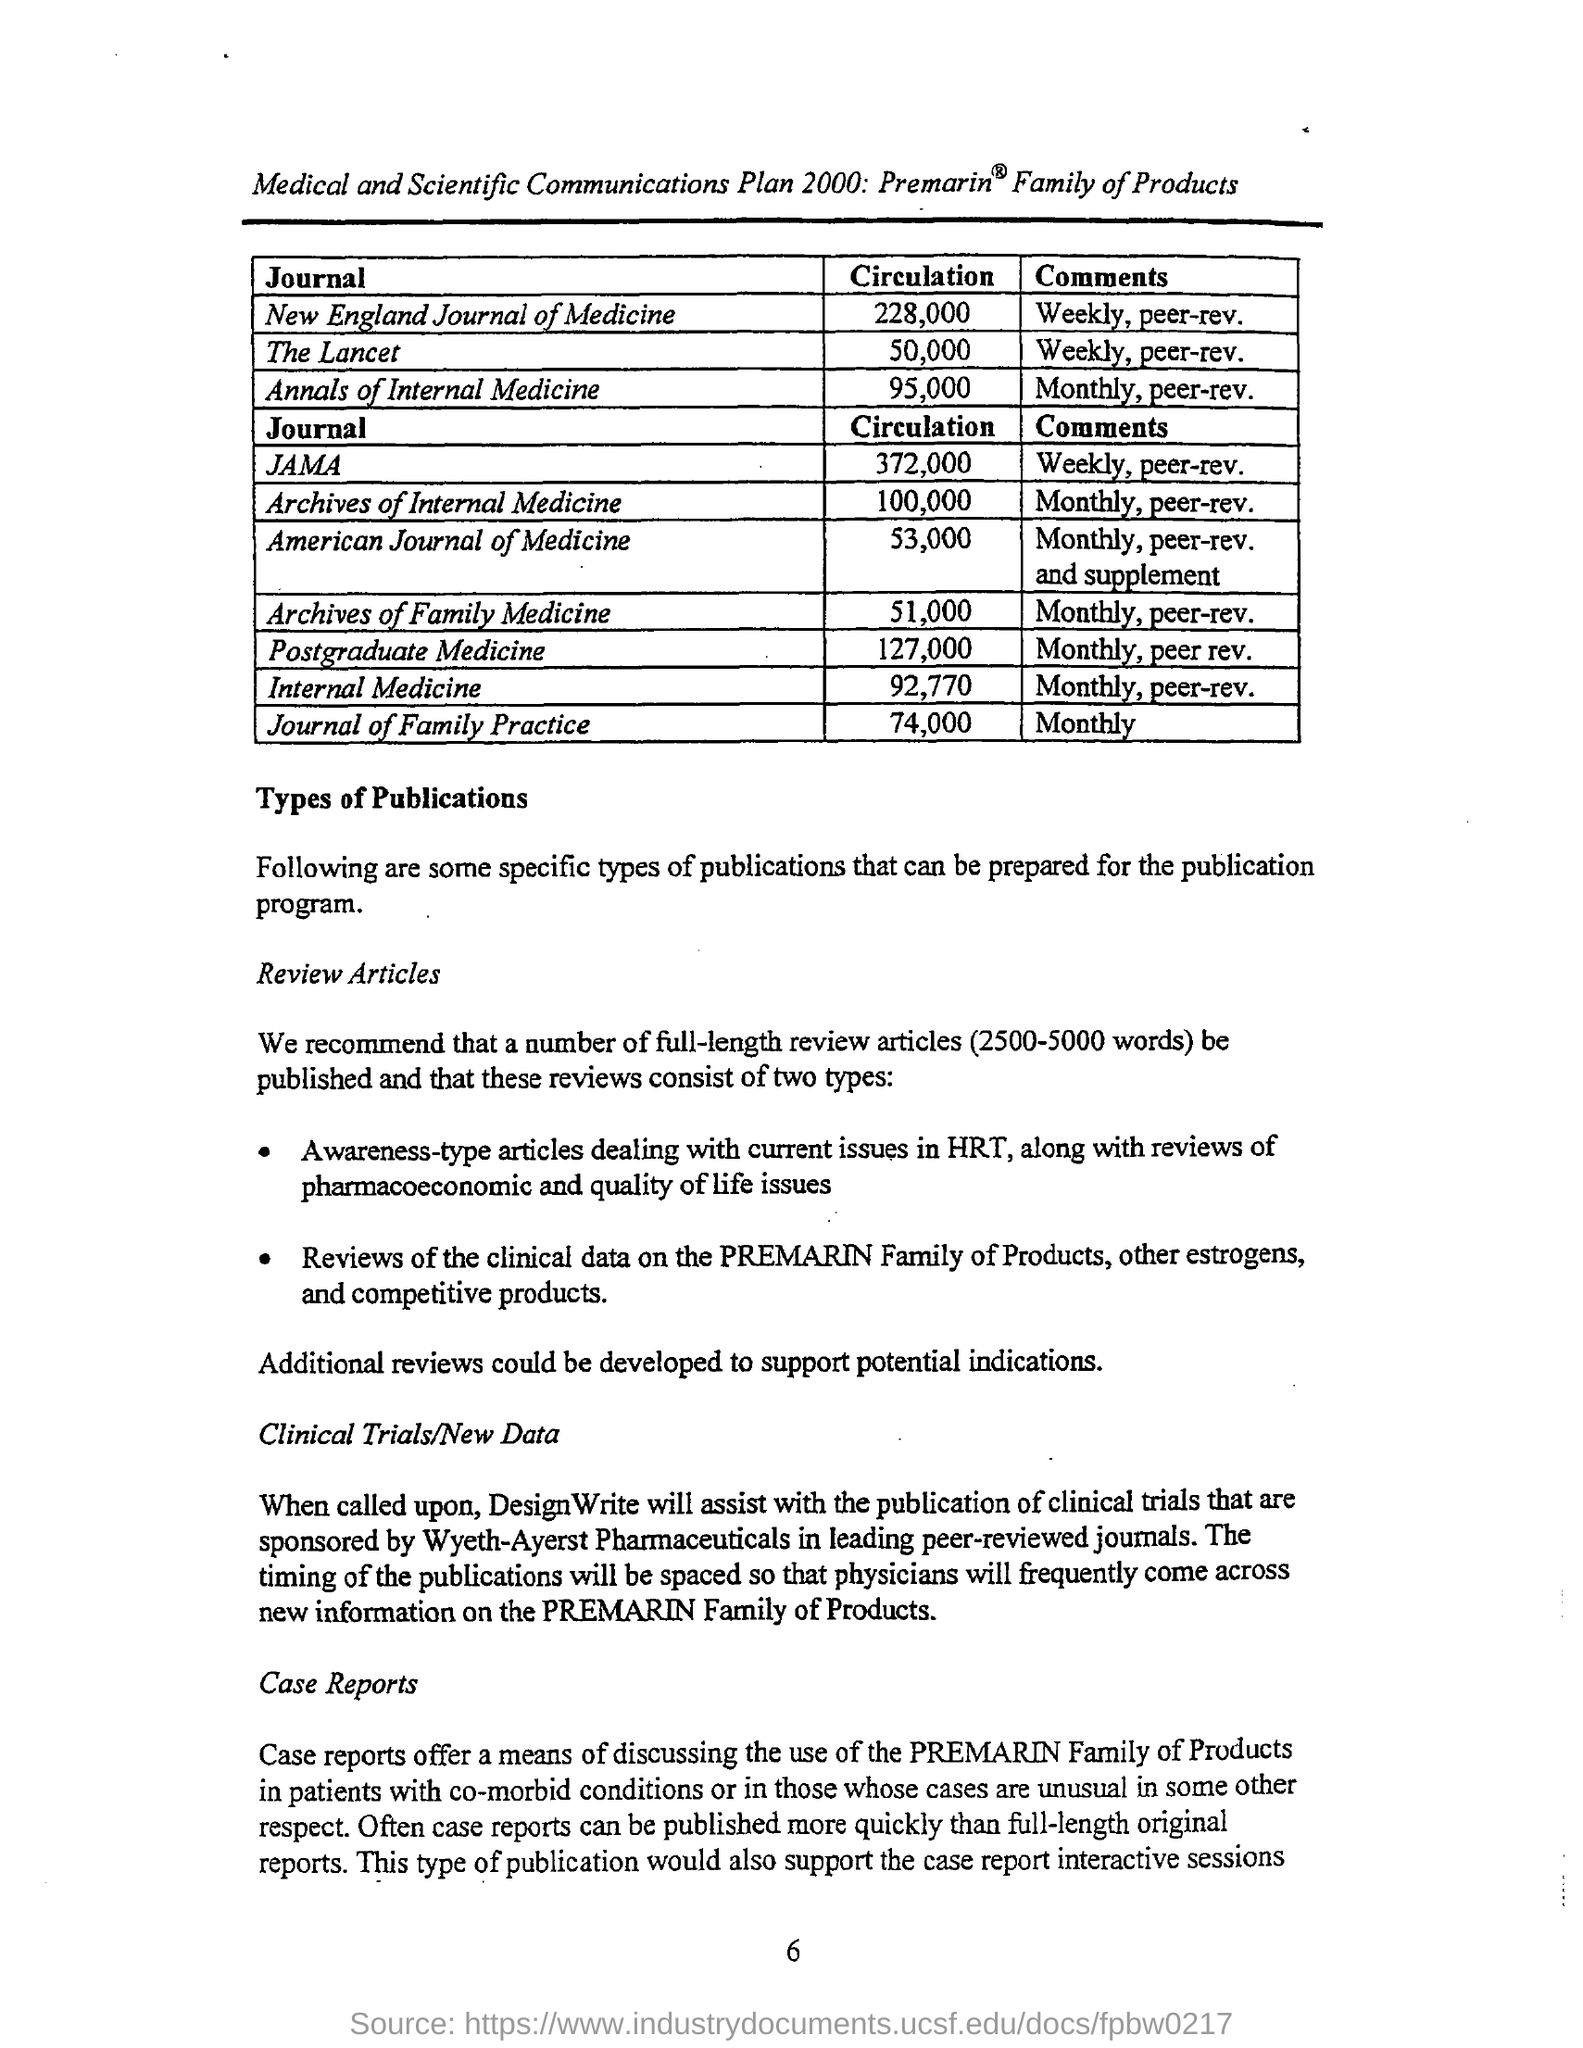What is the value of circulation for new england journal of medicine ?
Provide a short and direct response. 228,000. What is the value of circulation for the annals of internal medicine ?
Your answer should be very brief. 95,000. What are the comments for the lancet journal products ?
Offer a very short reply. Weekly , peer-rev. What is the circulation value for archives of internal medicine ?
Keep it short and to the point. 100,000. For which journal the circulation value is 53,000 ?
Offer a terse response. American journal of medicine. What are the comments mentioned for the journal of family practice ?
Offer a terse response. Monthly. What is the circulation value for postgraduate medicine mentioned in the given page ?
Give a very brief answer. 127,000. What is the value of circulation for the internal medicine mentioned in the given page ?
Your response must be concise. 92,770. What are the comments mentioned for the jama journal products ?
Your answer should be compact. Weekly, peer-rev. What is the circulation value for journal of family practice ?
Your response must be concise. 74,000. 